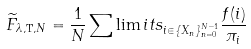Convert formula to latex. <formula><loc_0><loc_0><loc_500><loc_500>\widetilde { F } _ { \lambda , { \mathtt T } , N } = \frac { 1 } { N } \sum \lim i t s _ { i \in \{ X _ { n } \} _ { n = 0 } ^ { N - 1 } } \frac { f ( i ) } { \pi _ { i } }</formula> 